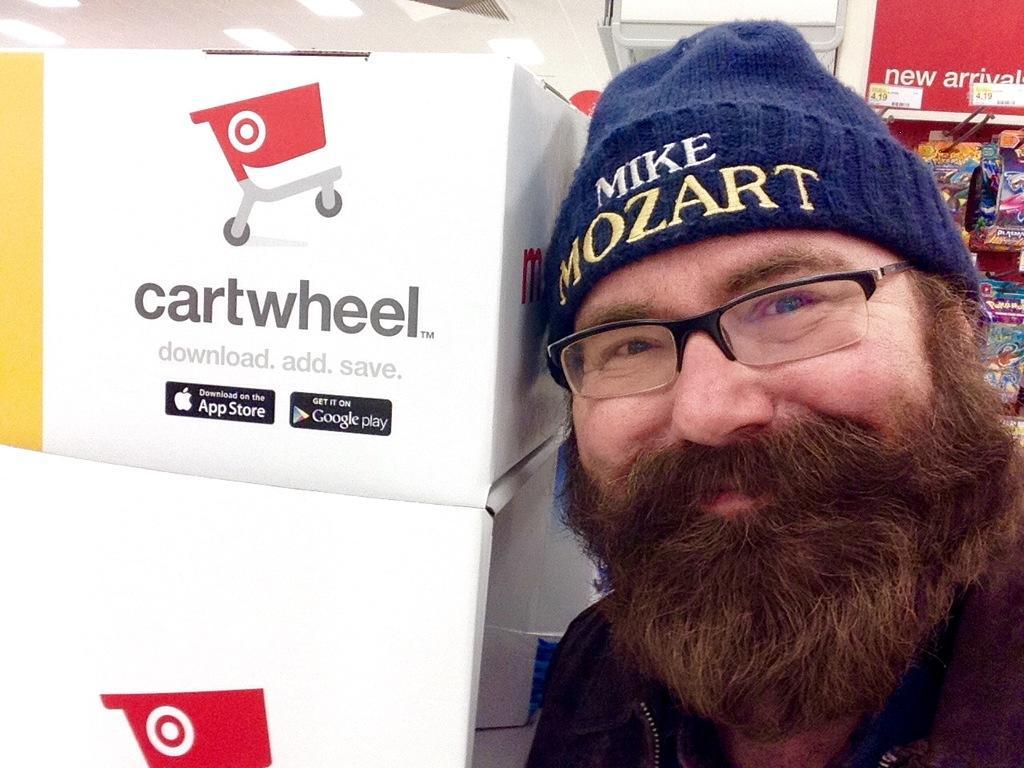Please provide a concise description of this image. In this picture, there is a man towards the right. Before him, there are carton boxes. On the top right, there are food packets hanged to the pole. 